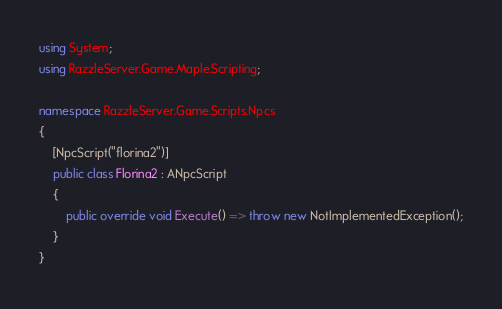<code> <loc_0><loc_0><loc_500><loc_500><_C#_>using System;
using RazzleServer.Game.Maple.Scripting;

namespace RazzleServer.Game.Scripts.Npcs
{
    [NpcScript("florina2")]
    public class Florina2 : ANpcScript
    {
        public override void Execute() => throw new NotImplementedException();
    }
}
</code> 